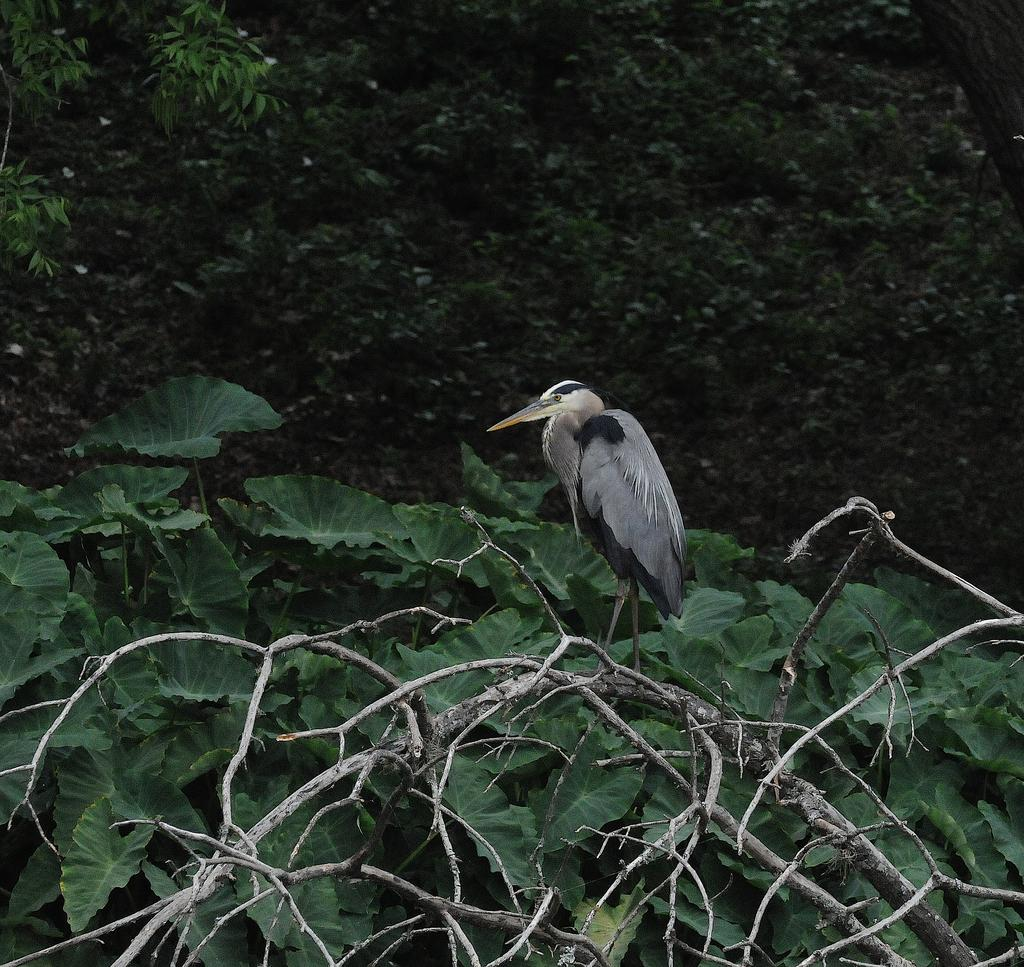What type of animal is in the image? There is a bird in the image. Where is the bird located? The bird is on a dry tree. What can be seen in the background of the image? There are leaves and trees in the background of the image. What type of wood is the bird using to build its nest in the image? There is no nest being built in the image, and no wood is mentioned or visible. 